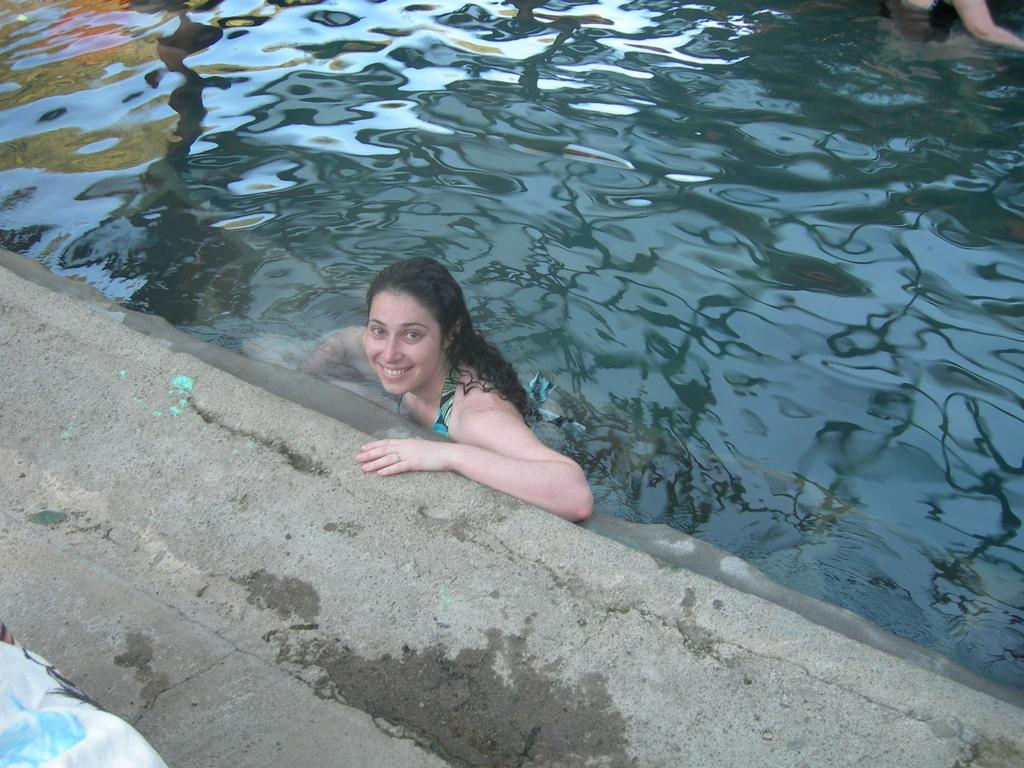Who is present in the image? There is a woman in the image. What is the woman doing in the image? The woman is smiling. Can you describe the other person in the image? The other person is in the water. What thoughts does the moon have about the woman's smile in the image? The moon is not present in the image, so it cannot have any thoughts about the woman's smile. 